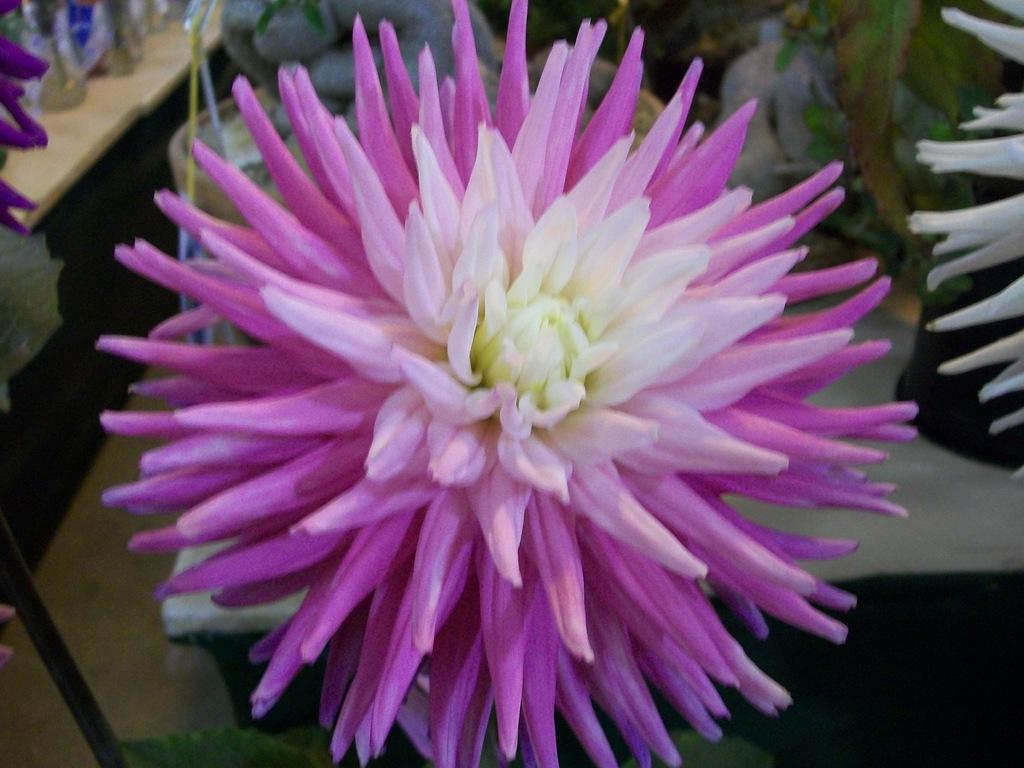What type of plants are in the image? There are flowering plants in the image. How are the flowering plants arranged or displayed? The flowering plants are in pots. Where are the pots with flowering plants located? The pots are on a table. Can you describe the setting where the table with pots is located? The image may have been taken in a hall. What is the texture of the sock in the image? There is no sock present in the image; it features flowering plants in pots on a table. 